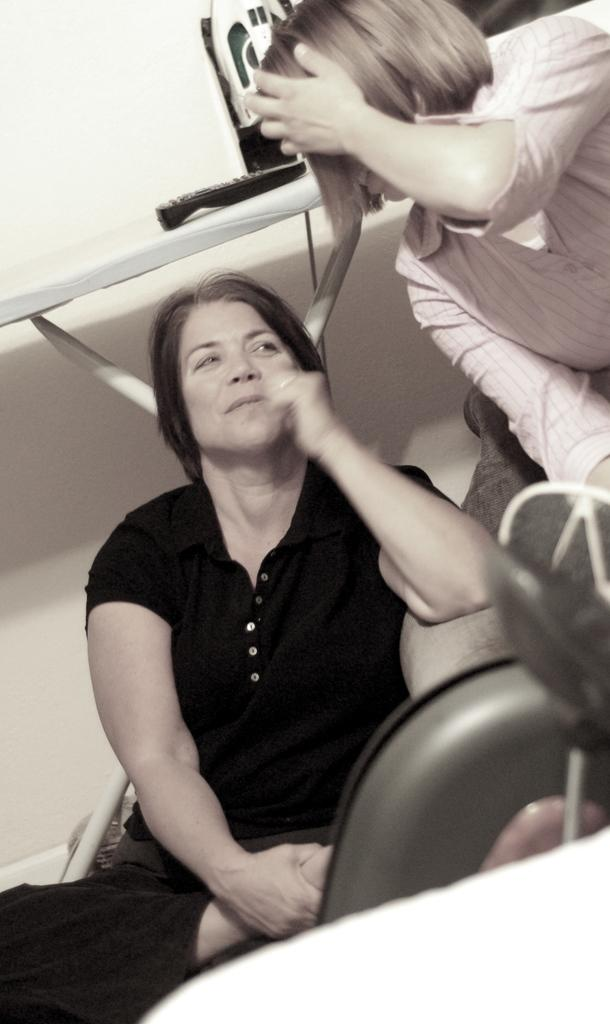How many people are present in the image? There are two people in the image. Can you describe any objects in the image? Yes, there is a remote on a table in the image. What type of trouble does the car face in the image? There is no car present in the image, so it is not possible to determine any trouble it might face. 